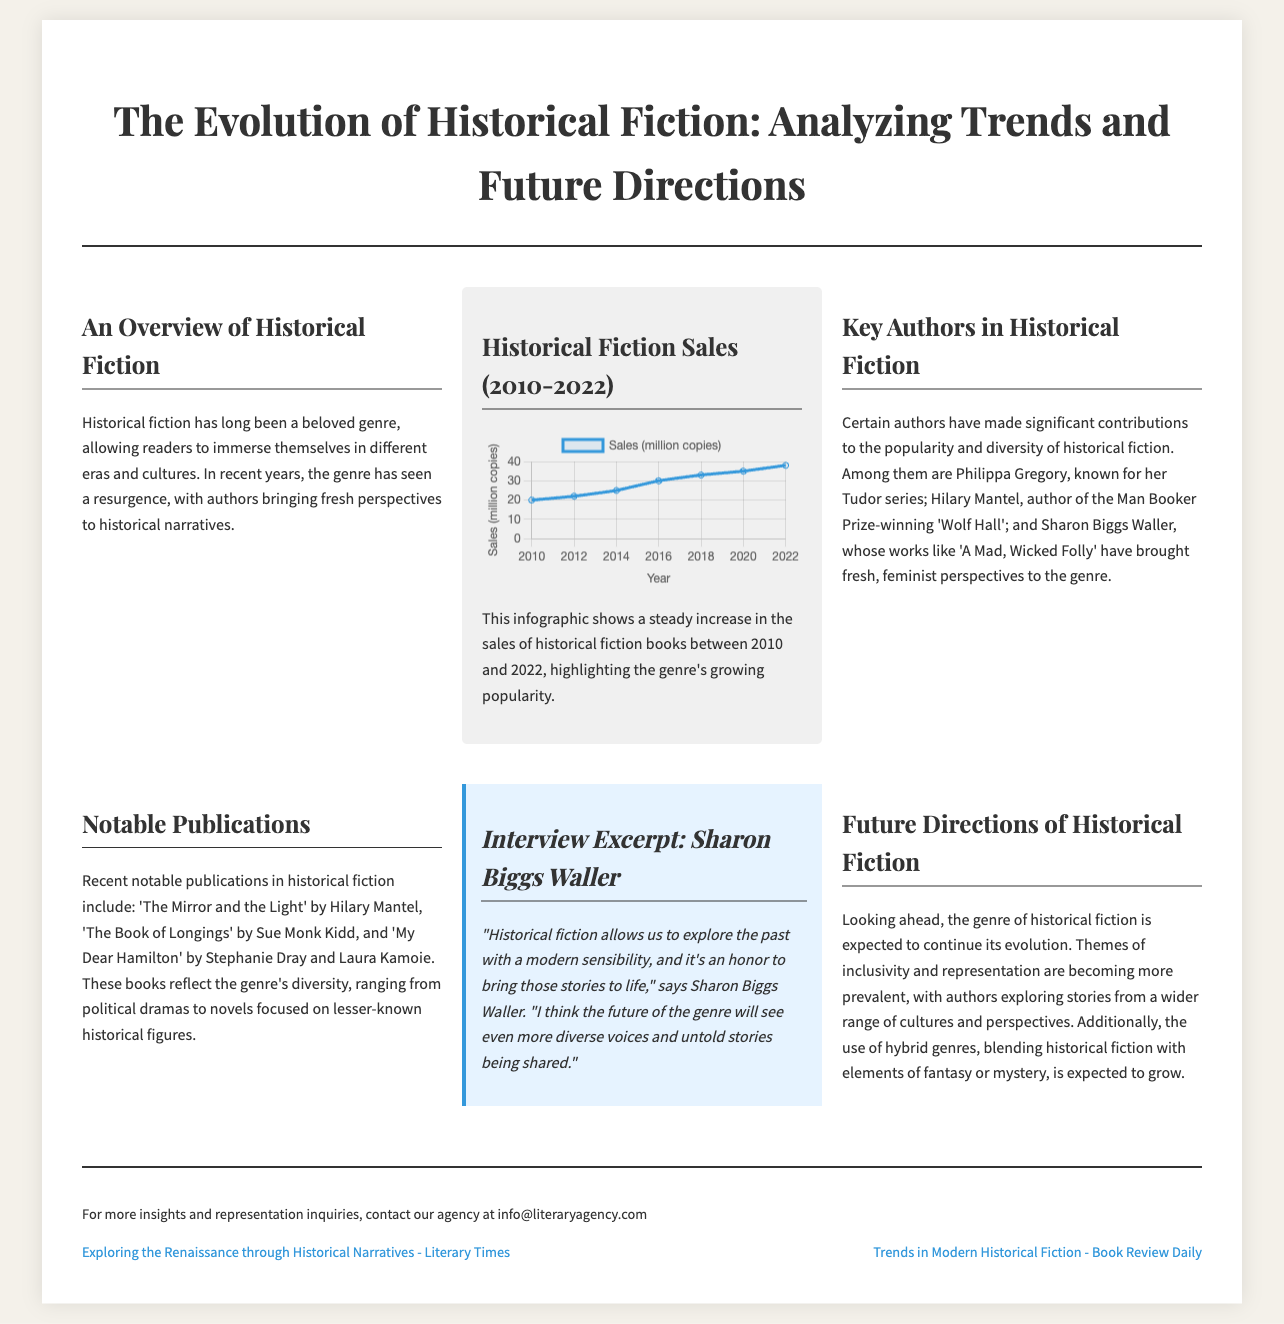What is the main focus of the article? The article discusses the evolution of historical fiction, including trends and future directions in the genre.
Answer: Evolution of historical fiction Who is a notable author mentioned for their Tudor series? Philippa Gregory is highlighted for her contributions to historical fiction, particularly known for her Tudor series.
Answer: Philippa Gregory What year marks the beginning of the sales data presented in the infographic? The sales chart starts with data from the year 2010, indicating the beginning of the observed period for historical fiction sales.
Answer: 2010 How many million copies of historical fiction were sold in 2022? According to the sales data, 38 million copies of historical fiction were sold in 2022.
Answer: 38 million Which prize did Hilary Mantel's book 'Wolf Hall' win? Hilary Mantel's 'Wolf Hall' is notably recognized for winning the Man Booker Prize, showcasing its impact in the genre.
Answer: Man Booker Prize What themes are expected to become more prevalent in the future of historical fiction? The article mentions themes of inclusivity and representation as key focuses for future developments in historical fiction.
Answer: Inclusivity and representation How does Sharon Biggs Waller view the future of historical fiction? In her interview excerpt, Sharon Biggs Waller expresses optimism about more diverse voices and untold stories being shared in the genre.
Answer: Diverse voices and untold stories What is the purpose of the related reading links at the end of the article? The related reading links aim to provide additional insights and perspectives related to the topic of historical fiction for further exploration.
Answer: Additional insights What type of chart is used to visualize historical fiction sales? The sales of historical fiction are visualized using a line chart, effectively illustrating the trend over the years.
Answer: Line chart 